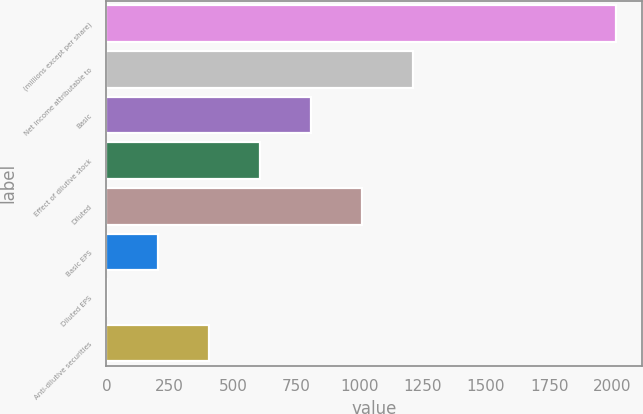<chart> <loc_0><loc_0><loc_500><loc_500><bar_chart><fcel>(millions except per share)<fcel>Net income attributable to<fcel>Basic<fcel>Effect of dilutive stock<fcel>Diluted<fcel>Basic EPS<fcel>Diluted EPS<fcel>Anti-dilutive securities<nl><fcel>2015<fcel>1210.34<fcel>808<fcel>606.83<fcel>1009.17<fcel>204.49<fcel>3.32<fcel>405.66<nl></chart> 